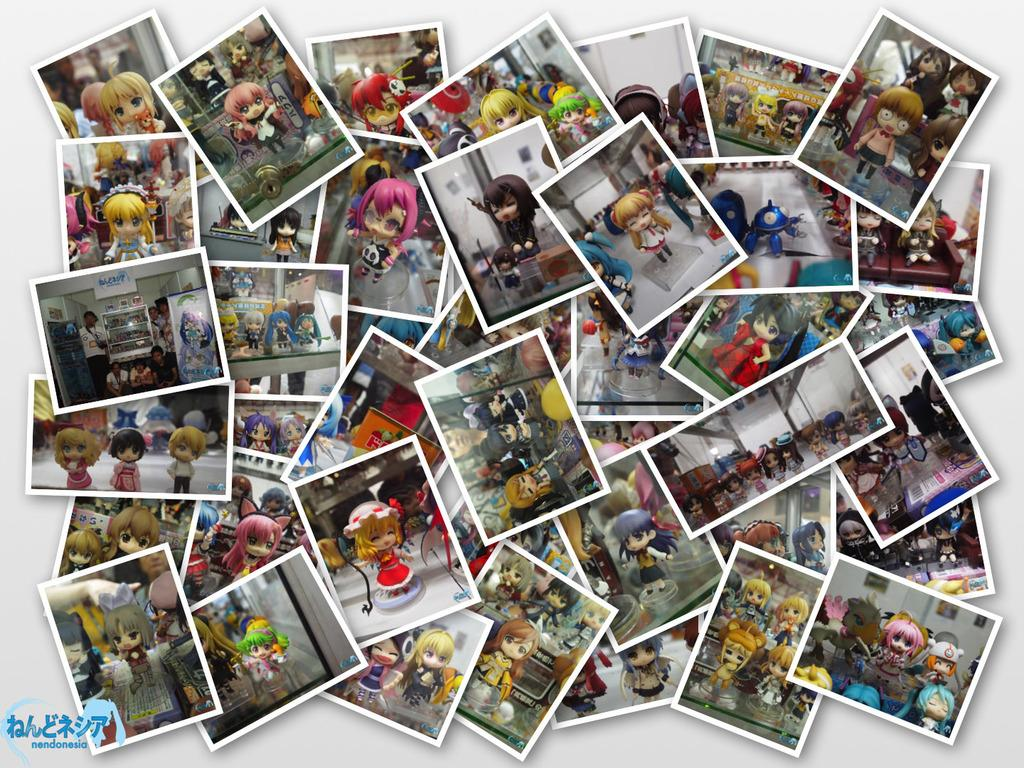What can be found on the bottom left of the image? There is a watermark on the bottom left of the image. What type of images are present in the background of the image? The background of the image contains animated images. What color is the background of the image? The background of the image is white in color. How many bikes are visible in the image? There are no bikes present in the image. Can you see a rake being used in the image? There is no rake visible in the image. 